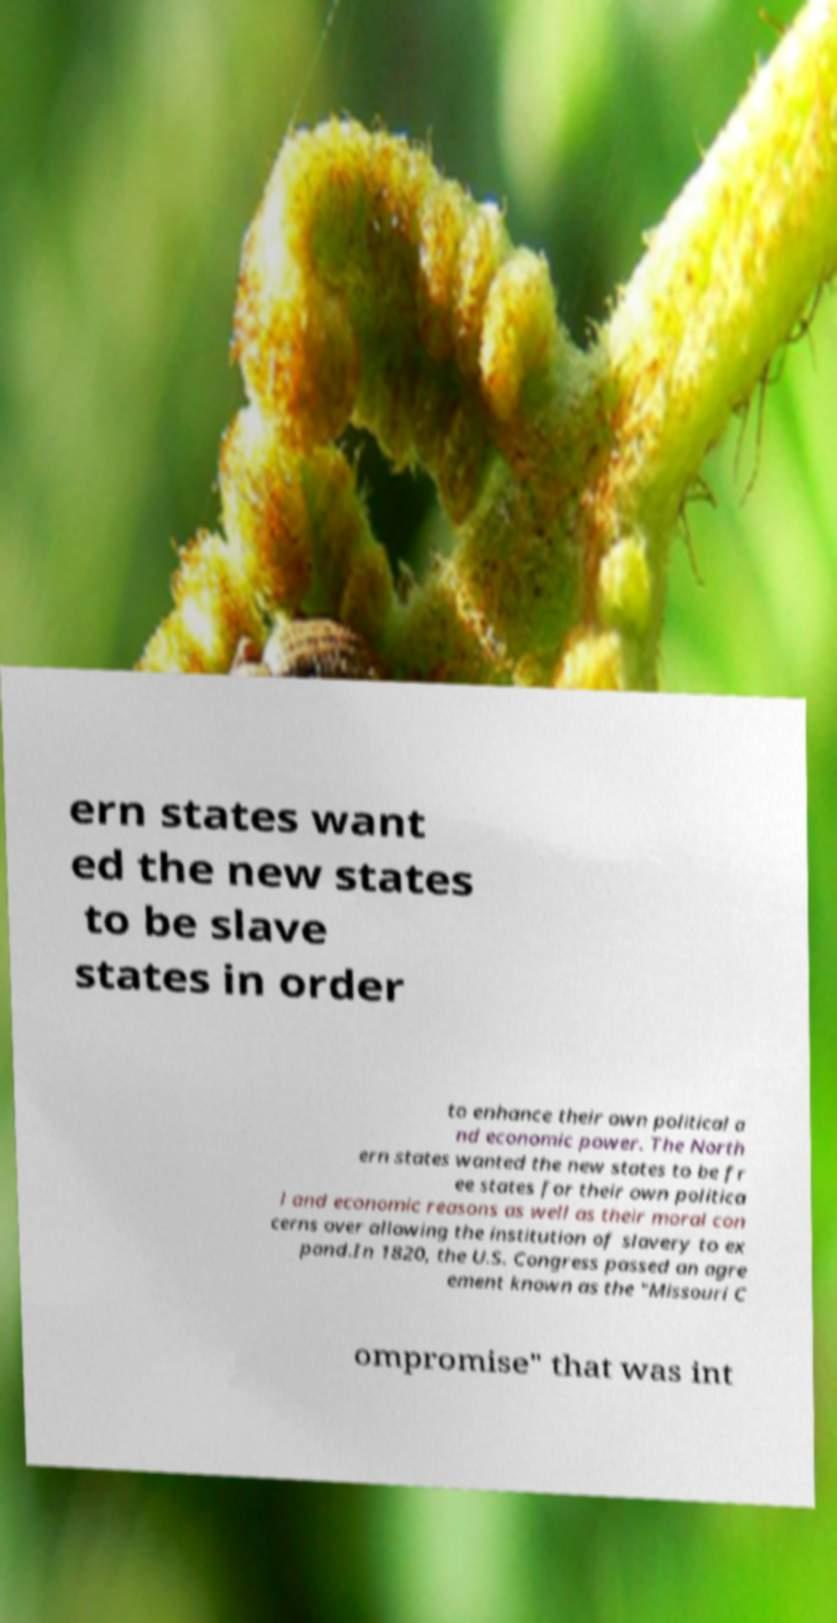Can you read and provide the text displayed in the image?This photo seems to have some interesting text. Can you extract and type it out for me? ern states want ed the new states to be slave states in order to enhance their own political a nd economic power. The North ern states wanted the new states to be fr ee states for their own politica l and economic reasons as well as their moral con cerns over allowing the institution of slavery to ex pand.In 1820, the U.S. Congress passed an agre ement known as the "Missouri C ompromise" that was int 